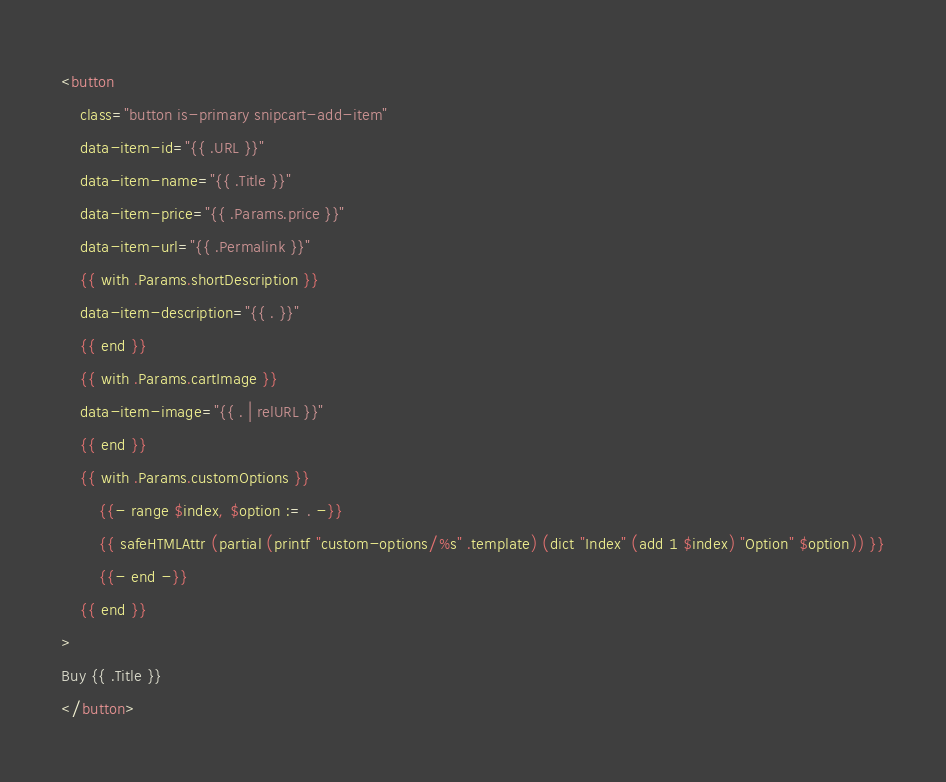<code> <loc_0><loc_0><loc_500><loc_500><_HTML_><button
    class="button is-primary snipcart-add-item"
    data-item-id="{{ .URL }}"
    data-item-name="{{ .Title }}"
    data-item-price="{{ .Params.price }}"
    data-item-url="{{ .Permalink }}"
    {{ with .Params.shortDescription }}
    data-item-description="{{ . }}"
    {{ end }}
    {{ with .Params.cartImage }}
    data-item-image="{{ . | relURL }}"
    {{ end }}
    {{ with .Params.customOptions }}
        {{- range $index, $option := . -}}
        {{ safeHTMLAttr (partial (printf "custom-options/%s" .template) (dict "Index" (add 1 $index) "Option" $option)) }}
        {{- end -}}
    {{ end }}
>
Buy {{ .Title }}
</button></code> 